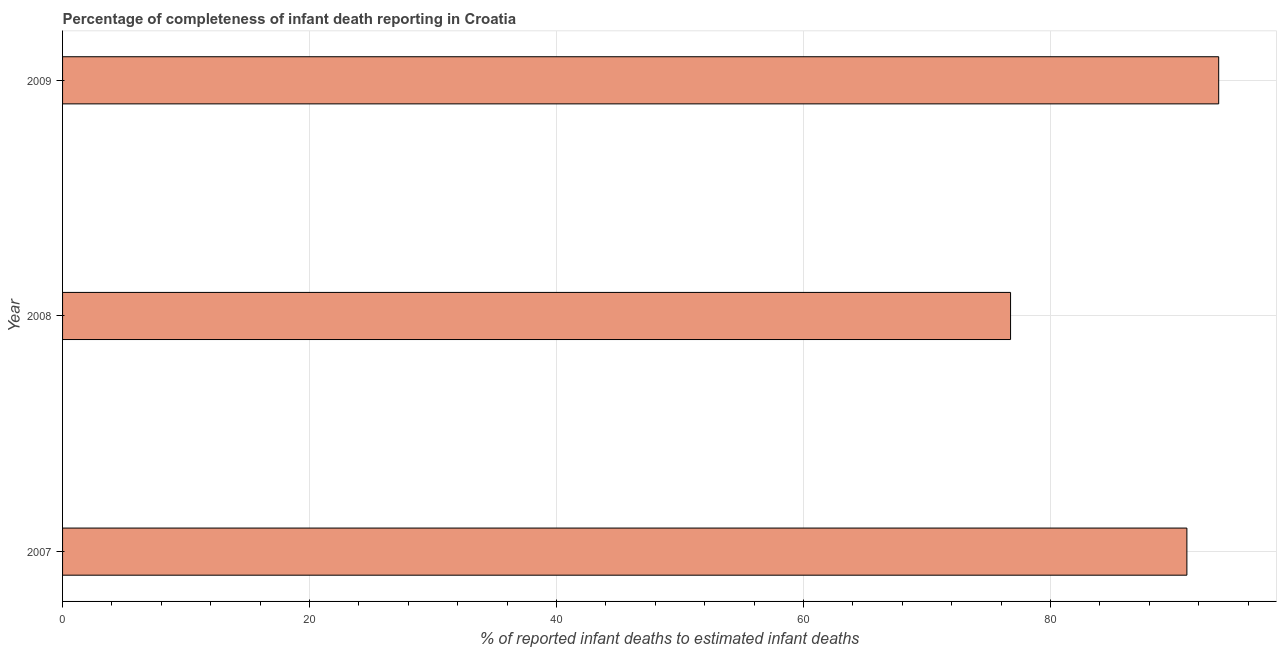Does the graph contain any zero values?
Keep it short and to the point. No. What is the title of the graph?
Your answer should be very brief. Percentage of completeness of infant death reporting in Croatia. What is the label or title of the X-axis?
Your response must be concise. % of reported infant deaths to estimated infant deaths. What is the label or title of the Y-axis?
Provide a succinct answer. Year. What is the completeness of infant death reporting in 2008?
Give a very brief answer. 76.77. Across all years, what is the maximum completeness of infant death reporting?
Your answer should be very brief. 93.63. Across all years, what is the minimum completeness of infant death reporting?
Provide a short and direct response. 76.77. In which year was the completeness of infant death reporting maximum?
Your answer should be compact. 2009. What is the sum of the completeness of infant death reporting?
Make the answer very short. 261.45. What is the difference between the completeness of infant death reporting in 2007 and 2009?
Offer a very short reply. -2.58. What is the average completeness of infant death reporting per year?
Your response must be concise. 87.15. What is the median completeness of infant death reporting?
Your response must be concise. 91.05. In how many years, is the completeness of infant death reporting greater than 40 %?
Provide a short and direct response. 3. Do a majority of the years between 2008 and 2009 (inclusive) have completeness of infant death reporting greater than 32 %?
Offer a very short reply. Yes. What is the ratio of the completeness of infant death reporting in 2007 to that in 2008?
Your answer should be very brief. 1.19. What is the difference between the highest and the second highest completeness of infant death reporting?
Provide a succinct answer. 2.58. What is the difference between the highest and the lowest completeness of infant death reporting?
Ensure brevity in your answer.  16.85. How many bars are there?
Keep it short and to the point. 3. Are all the bars in the graph horizontal?
Your answer should be compact. Yes. What is the difference between two consecutive major ticks on the X-axis?
Your answer should be very brief. 20. What is the % of reported infant deaths to estimated infant deaths in 2007?
Your answer should be very brief. 91.05. What is the % of reported infant deaths to estimated infant deaths of 2008?
Make the answer very short. 76.77. What is the % of reported infant deaths to estimated infant deaths of 2009?
Ensure brevity in your answer.  93.63. What is the difference between the % of reported infant deaths to estimated infant deaths in 2007 and 2008?
Your response must be concise. 14.28. What is the difference between the % of reported infant deaths to estimated infant deaths in 2007 and 2009?
Keep it short and to the point. -2.57. What is the difference between the % of reported infant deaths to estimated infant deaths in 2008 and 2009?
Offer a very short reply. -16.85. What is the ratio of the % of reported infant deaths to estimated infant deaths in 2007 to that in 2008?
Give a very brief answer. 1.19. What is the ratio of the % of reported infant deaths to estimated infant deaths in 2007 to that in 2009?
Offer a terse response. 0.97. What is the ratio of the % of reported infant deaths to estimated infant deaths in 2008 to that in 2009?
Make the answer very short. 0.82. 